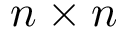Convert formula to latex. <formula><loc_0><loc_0><loc_500><loc_500>n \times n</formula> 